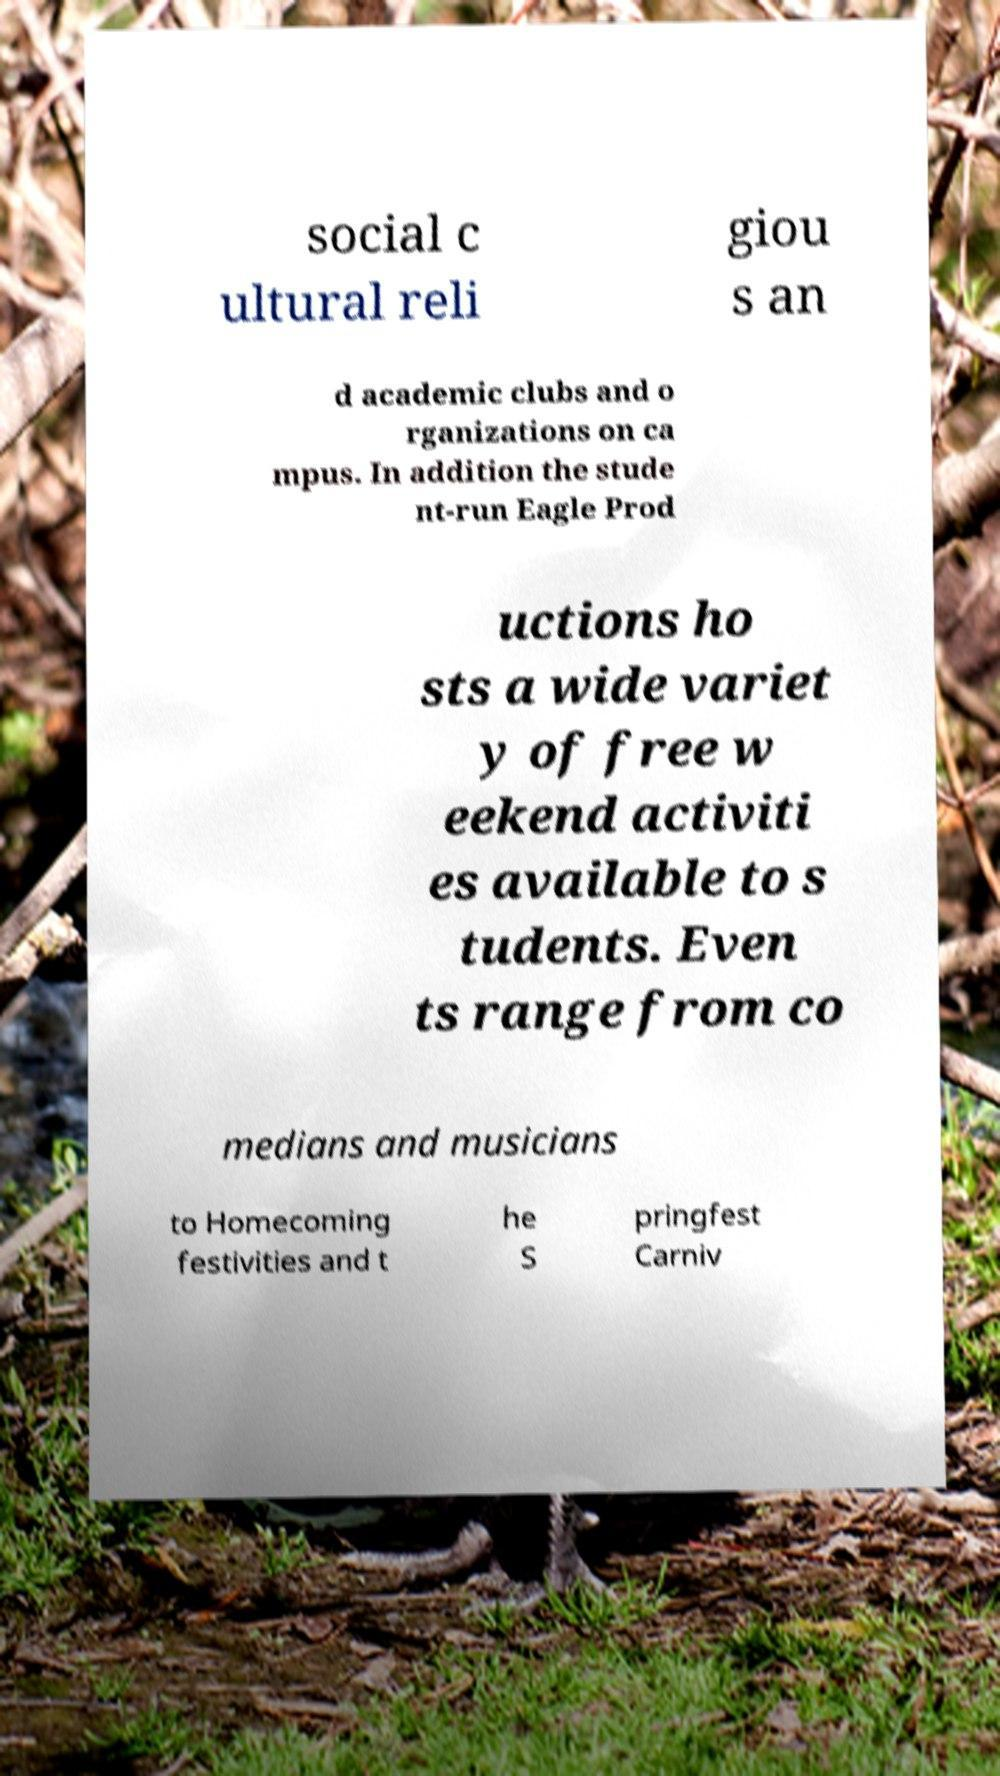Can you read and provide the text displayed in the image?This photo seems to have some interesting text. Can you extract and type it out for me? social c ultural reli giou s an d academic clubs and o rganizations on ca mpus. In addition the stude nt-run Eagle Prod uctions ho sts a wide variet y of free w eekend activiti es available to s tudents. Even ts range from co medians and musicians to Homecoming festivities and t he S pringfest Carniv 